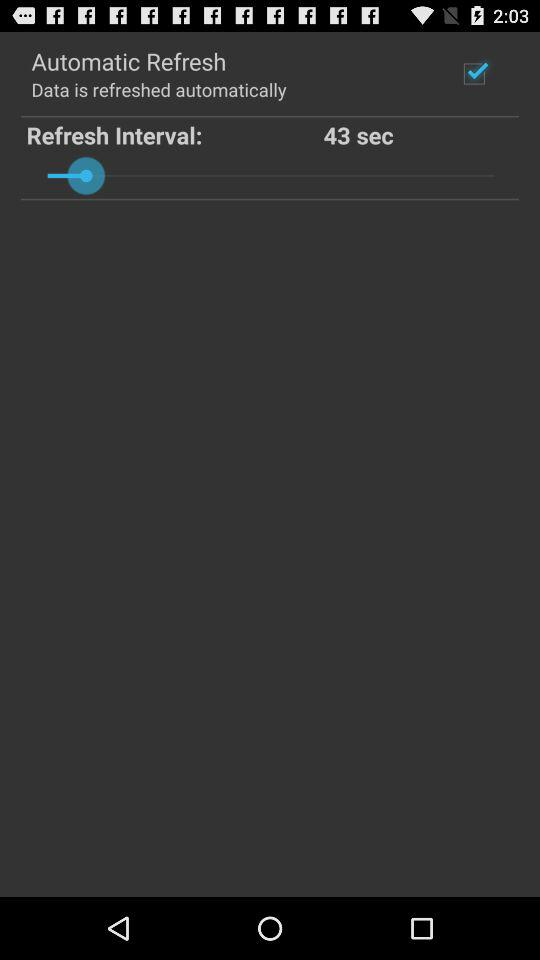How many seconds is the refresh interval?
Answer the question using a single word or phrase. 43 